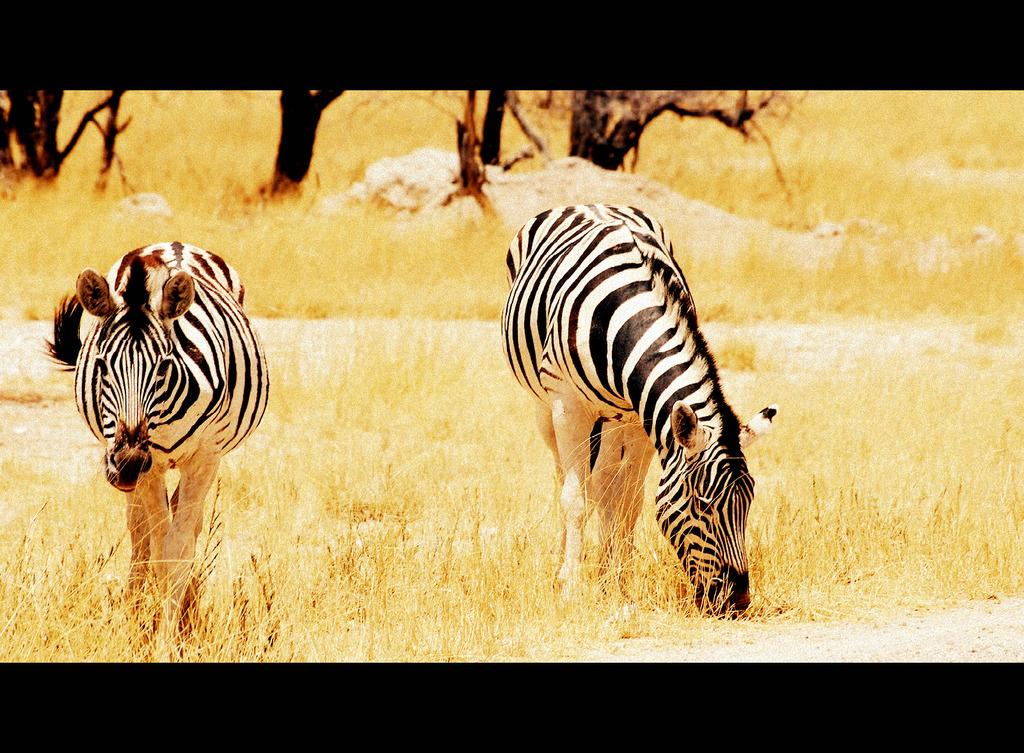How many zebras are in the image? There are two zebras in the image. What are the zebras doing in the image? The zebras are standing on the ground, and the right zebra is eating grass. What can be seen in the background of the image? There are stones, grass, and trees visible in the background of the image. What type of protest is the zebra participating in the image? There is no protest present in the image; the zebras are simply standing and eating grass. What is the memory capacity of the zebra in the image? There is no information about the memory capacity of the zebra in the image, as it is a photograph and not a living creature with cognitive abilities. 